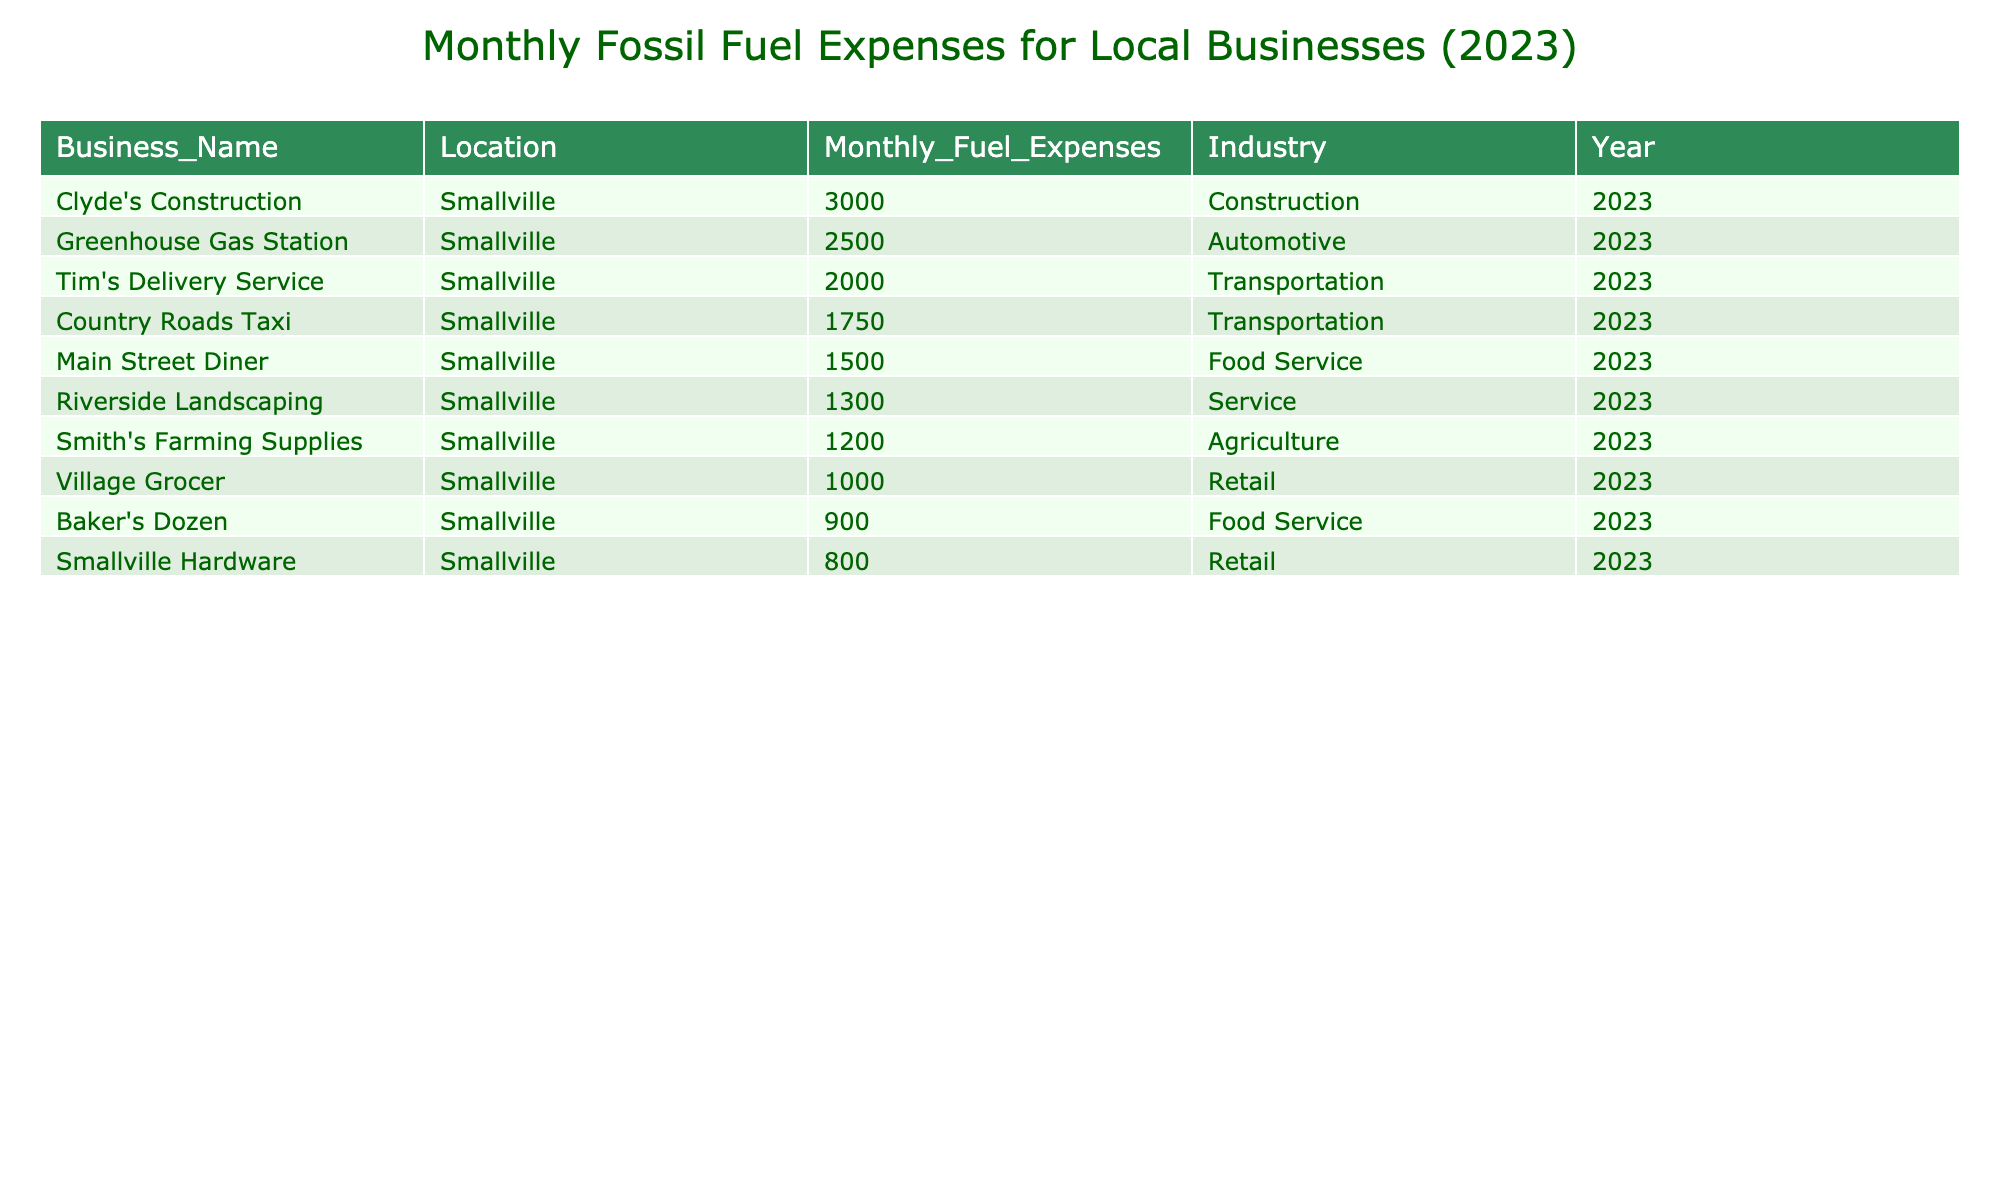What is the highest monthly fuel expense among the businesses? The highest value can be found by looking at the "Monthly_Fuel_Expenses" column, which is 3000 from Clyde's Construction.
Answer: 3000 What industry does the business with the lowest fuel expense belong to? The lowest monthly fuel expense is 800, which is associated with Smallville Hardware, belonging to the Retail industry.
Answer: Retail What is the total monthly fuel expense for all the businesses listed? By summing all the values in the "Monthly_Fuel_Expenses" column, we get 1500 + 800 + 2000 + 1200 + 2500 + 1000 + 900 + 1300 + 3000 + 1750 = 14,950.
Answer: 14950 How much more does Clyde's Construction spend on fuel compared to the Village Grocer? Clyde's Construction spends 3000 while Village Grocer spends 1000, so the difference is 3000 - 1000 = 2000.
Answer: 2000 How many businesses in the Transportation industry have fuel expenses exceeding 1500? Tim's Delivery Service spends 2000, and Country Roads Taxi spends 1750; both exceed 1500. Therefore, there are 2 businesses in that industry.
Answer: 2 Is the Village Grocer's fuel expense greater than 900? The Village Grocer's fuel expense is 1000, which is indeed greater than 900.
Answer: Yes What is the average monthly fuel expense of all businesses in the Agriculture industry? There is one business, Smith's Farming Supplies, with a fuel expense of 1200, so the average is also 1200 since it's the only data point.
Answer: 1200 Among all the businesses, how many are in the Food Service sector? Main Street Diner and Baker's Dozen are both in the Food Service sector, making it a total of 2 businesses.
Answer: 2 How much do the Retail businesses collectively spend on fuel? Smallville Hardware spends 800, and Village Grocer spends 1000; adding these gives 800 + 1000 = 1800.
Answer: 1800 What percentage of total monthly fuel expenses is attributed to the Automotive industry? Greenhouse Gas Station spends 2500 out of a total of 14950, so (2500 / 14950) * 100 = approximately 16.7%.
Answer: 16.7% 